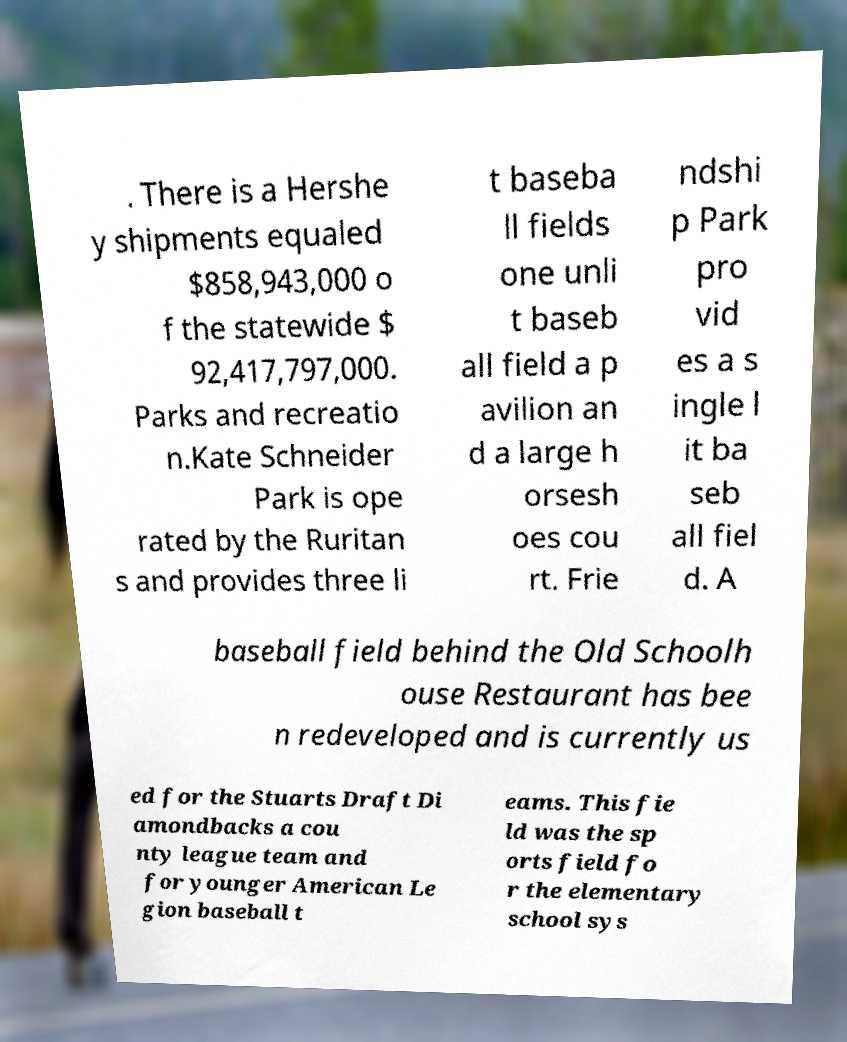Can you read and provide the text displayed in the image?This photo seems to have some interesting text. Can you extract and type it out for me? . There is a Hershe y shipments equaled $858,943,000 o f the statewide $ 92,417,797,000. Parks and recreatio n.Kate Schneider Park is ope rated by the Ruritan s and provides three li t baseba ll fields one unli t baseb all field a p avilion an d a large h orsesh oes cou rt. Frie ndshi p Park pro vid es a s ingle l it ba seb all fiel d. A baseball field behind the Old Schoolh ouse Restaurant has bee n redeveloped and is currently us ed for the Stuarts Draft Di amondbacks a cou nty league team and for younger American Le gion baseball t eams. This fie ld was the sp orts field fo r the elementary school sys 